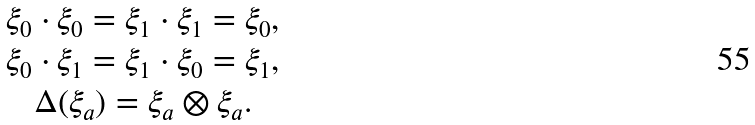<formula> <loc_0><loc_0><loc_500><loc_500>\begin{array} { c } \xi _ { 0 } \cdot \xi _ { 0 } = \xi _ { 1 } \cdot \xi _ { 1 } = \xi _ { 0 } , \\ \xi _ { 0 } \cdot \xi _ { 1 } = \xi _ { 1 } \cdot \xi _ { 0 } = \xi _ { 1 } , \\ \Delta ( \xi _ { a } ) = \xi _ { a } \otimes \xi _ { a } . \end{array}</formula> 